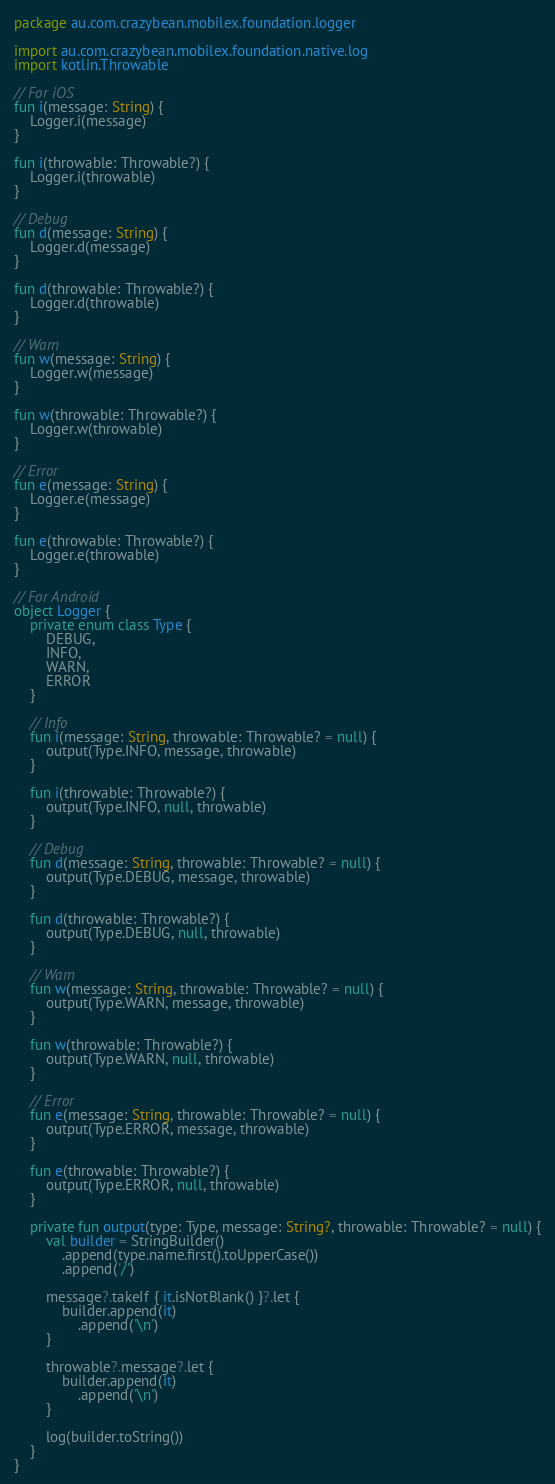Convert code to text. <code><loc_0><loc_0><loc_500><loc_500><_Kotlin_>package au.com.crazybean.mobilex.foundation.logger

import au.com.crazybean.mobilex.foundation.native.log
import kotlin.Throwable

// For iOS
fun i(message: String) {
    Logger.i(message)
}

fun i(throwable: Throwable?) {
    Logger.i(throwable)
}

// Debug
fun d(message: String) {
    Logger.d(message)
}

fun d(throwable: Throwable?) {
    Logger.d(throwable)
}

// Warn
fun w(message: String) {
    Logger.w(message)
}

fun w(throwable: Throwable?) {
    Logger.w(throwable)
}

// Error
fun e(message: String) {
    Logger.e(message)
}

fun e(throwable: Throwable?) {
    Logger.e(throwable)
}

// For Android
object Logger {
    private enum class Type {
        DEBUG,
        INFO,
        WARN,
        ERROR
    }

    // Info
    fun i(message: String, throwable: Throwable? = null) {
        output(Type.INFO, message, throwable)
    }

    fun i(throwable: Throwable?) {
        output(Type.INFO, null, throwable)
    }

    // Debug
    fun d(message: String, throwable: Throwable? = null) {
        output(Type.DEBUG, message, throwable)
    }

    fun d(throwable: Throwable?) {
        output(Type.DEBUG, null, throwable)
    }

    // Warn
    fun w(message: String, throwable: Throwable? = null) {
        output(Type.WARN, message, throwable)
    }

    fun w(throwable: Throwable?) {
        output(Type.WARN, null, throwable)
    }

    // Error
    fun e(message: String, throwable: Throwable? = null) {
        output(Type.ERROR, message, throwable)
    }

    fun e(throwable: Throwable?) {
        output(Type.ERROR, null, throwable)
    }

    private fun output(type: Type, message: String?, throwable: Throwable? = null) {
        val builder = StringBuilder()
            .append(type.name.first().toUpperCase())
            .append('/')

        message?.takeIf { it.isNotBlank() }?.let {
            builder.append(it)
                .append('\n')
        }

        throwable?.message?.let {
            builder.append(it)
                .append('\n')
        }

        log(builder.toString())
    }
}</code> 